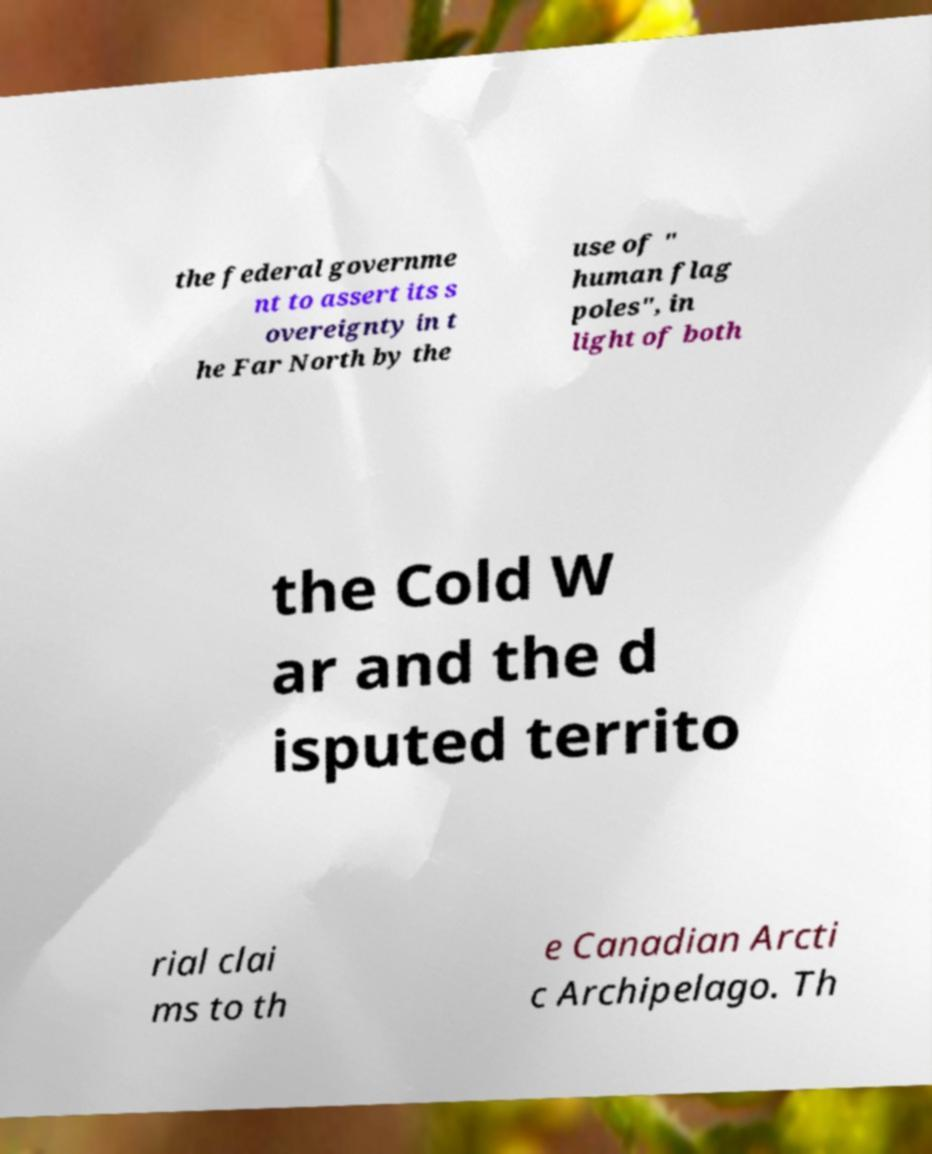I need the written content from this picture converted into text. Can you do that? the federal governme nt to assert its s overeignty in t he Far North by the use of " human flag poles", in light of both the Cold W ar and the d isputed territo rial clai ms to th e Canadian Arcti c Archipelago. Th 